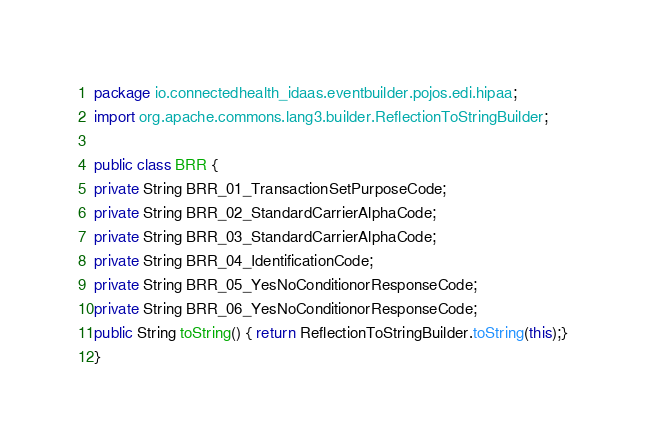<code> <loc_0><loc_0><loc_500><loc_500><_Java_>package io.connectedhealth_idaas.eventbuilder.pojos.edi.hipaa;
import org.apache.commons.lang3.builder.ReflectionToStringBuilder;

public class BRR {
private String BRR_01_TransactionSetPurposeCode;
private String BRR_02_StandardCarrierAlphaCode;
private String BRR_03_StandardCarrierAlphaCode;
private String BRR_04_IdentificationCode;
private String BRR_05_YesNoConditionorResponseCode;
private String BRR_06_YesNoConditionorResponseCode;
public String toString() { return ReflectionToStringBuilder.toString(this);}
}

</code> 